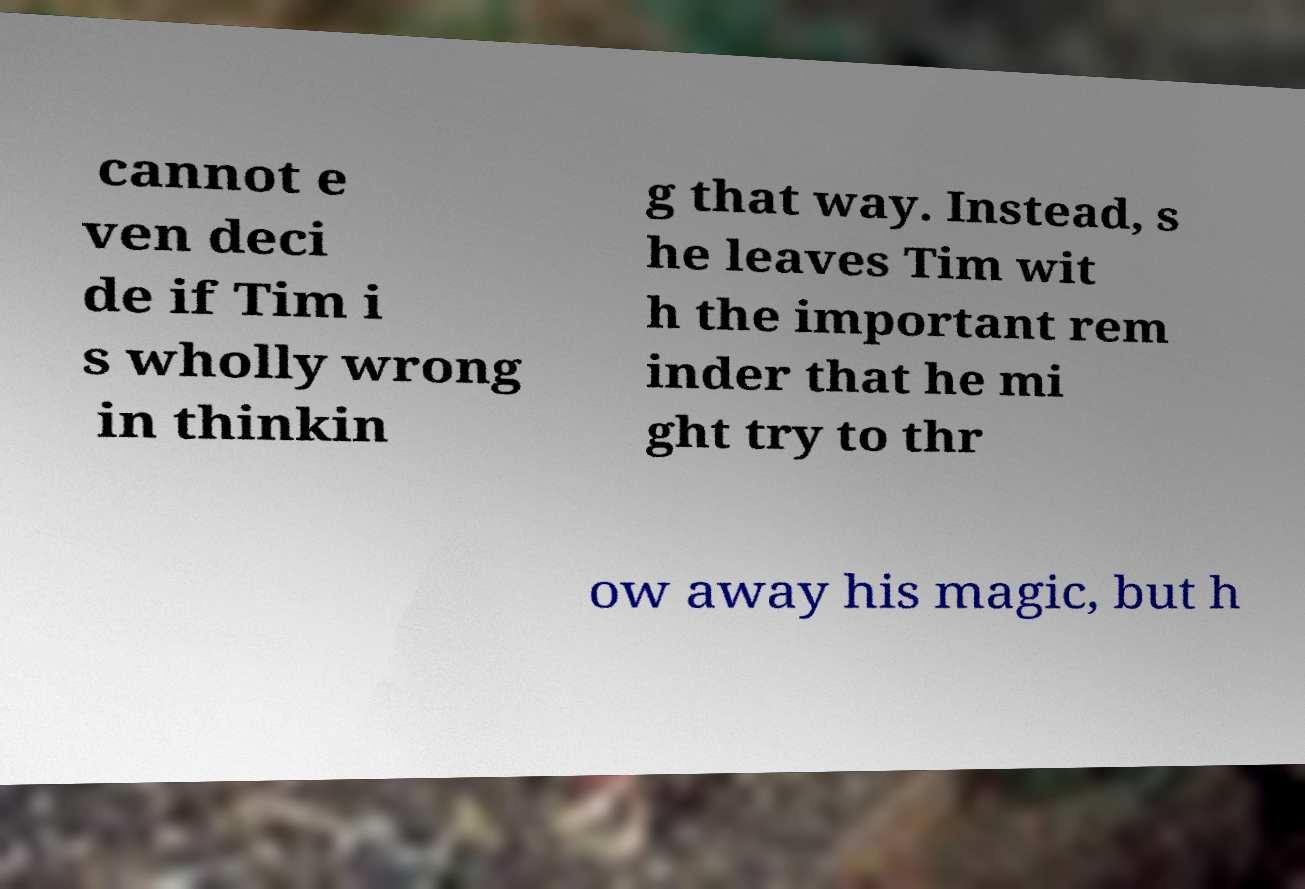Can you read and provide the text displayed in the image?This photo seems to have some interesting text. Can you extract and type it out for me? cannot e ven deci de if Tim i s wholly wrong in thinkin g that way. Instead, s he leaves Tim wit h the important rem inder that he mi ght try to thr ow away his magic, but h 